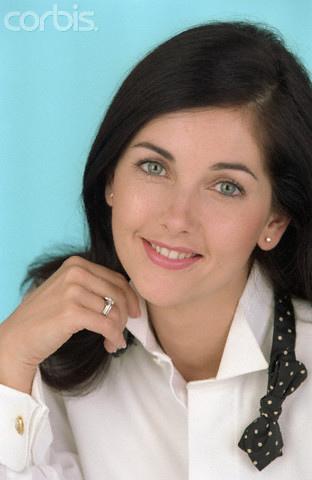Is this woman friendly?
Quick response, please. Yes. Which nostril has a ring?
Short answer required. 0. Does she appear happy?
Answer briefly. Yes. Are her earrings pierced or clip-on?
Answer briefly. Pierced. Is she wearing a bowtie?
Be succinct. Yes. 